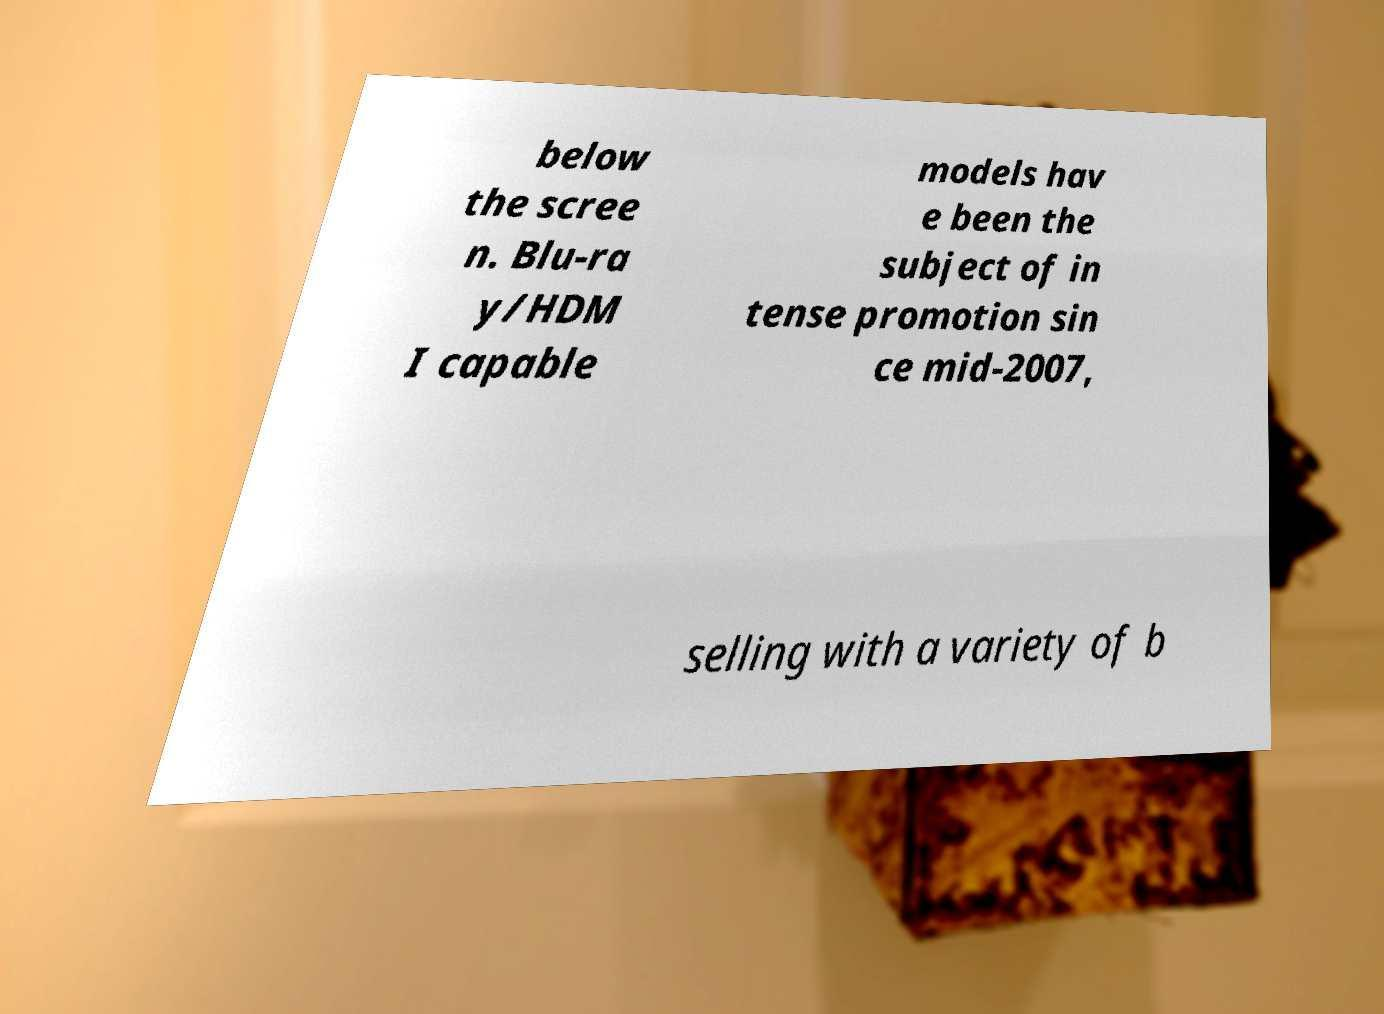Could you assist in decoding the text presented in this image and type it out clearly? below the scree n. Blu-ra y/HDM I capable models hav e been the subject of in tense promotion sin ce mid-2007, selling with a variety of b 